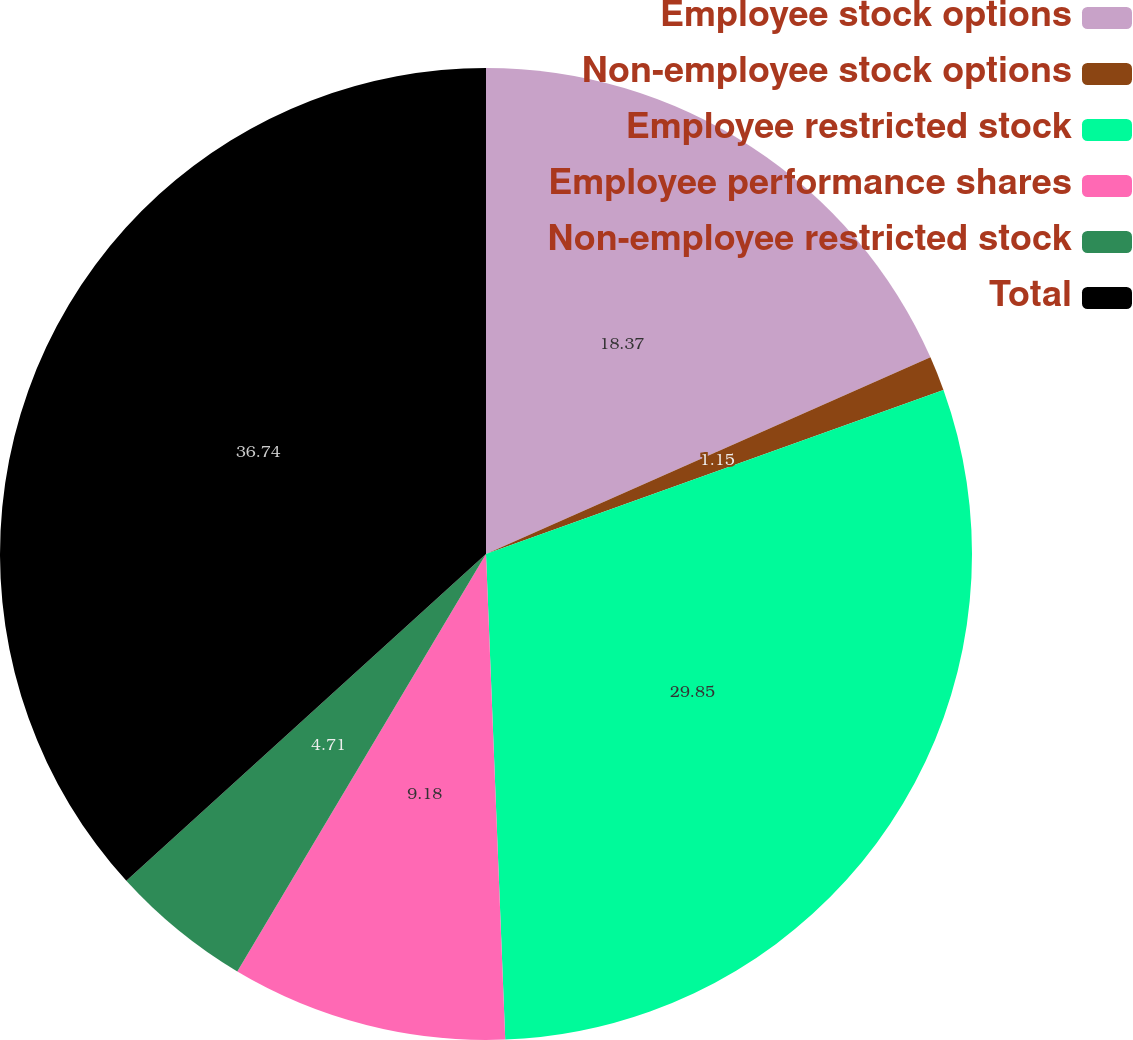Convert chart. <chart><loc_0><loc_0><loc_500><loc_500><pie_chart><fcel>Employee stock options<fcel>Non-employee stock options<fcel>Employee restricted stock<fcel>Employee performance shares<fcel>Non-employee restricted stock<fcel>Total<nl><fcel>18.37%<fcel>1.15%<fcel>29.85%<fcel>9.18%<fcel>4.71%<fcel>36.74%<nl></chart> 